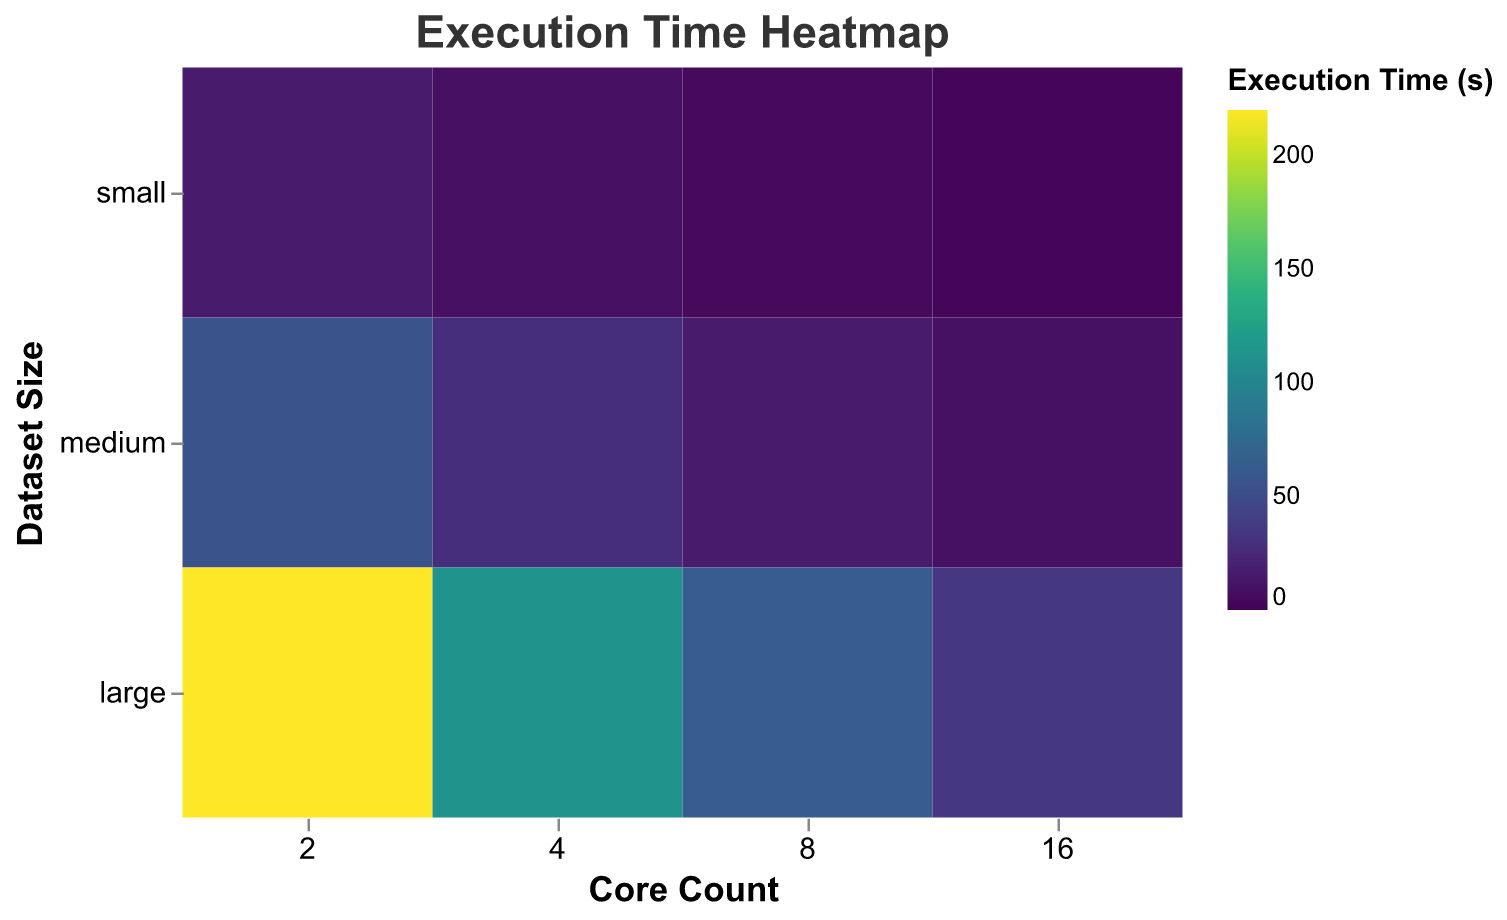What is the title of the heatmap? The title of the heatmap is placed at the top and is clearly stated in the code.
Answer: Execution Time Heatmap How does the execution time change with the increase in core count for a small dataset? By examining the colors in the rows corresponding to the small dataset and comparing them from left to right (2 cores to 16 cores), we can observe a color transition from darker to lighter, which indicates decreasing execution times.
Answer: It decreases For a medium dataset, what is the execution time for 8 cores? Finding the intersecting cell in the heatmap where the medium dataset and 8 cores meet shows the specific execution time value.
Answer: 15.2 seconds Which dataset size has the longest execution time for 2 cores? Examine the cells in the heatmap's column for 2 cores and compare the colors. The darkest color indicates the longest execution time.
Answer: Large dataset As the core count increases from 2 to 16, which dataset size shows the most significant reduction in execution time? By following the columns for each dataset size and observing the color transition from dark to light, we can determine which dataset size shows the most significant reduction.
Answer: Large dataset Does increasing the core count always reduce execution time for all dataset sizes? Comparing the colors across rows for each dataset size (small, medium, and large) shows consistent lightening of color, indicating reduced execution times.
Answer: Yes Which combinations of core count and dataset size result in execution times under 10 seconds? Identify the cells with the lightest colors and verify the execution time values by looking at the heatmap scale. Check each dataset size across different core counts.
Answer: 4 cores-small, 8 cores-small, 8 cores-medium, 16 cores-small, 16 cores-medium How does execution time for medium datasets compare between 4 and 8 cores? Find and compare the colors and values for the cells corresponding to medium dataset size at 4 cores and 8 cores.
Answer: 28.4 seconds for 4 cores, 15.2 seconds for 8 cores What is the difference in execution time between 4 and 16 cores for a large dataset? Locate the cells where large dataset intersects with 4 cores and 16 cores, then subtract the value of 16 cores from 4 cores.
Answer: 112.0 - 34.7 = 77.3 seconds For which core count does the execution time drop below 5 seconds for the first time with a small dataset size? Find the row corresponding to the small dataset and check each column until the execution time is below 5 seconds.
Answer: 8 cores 